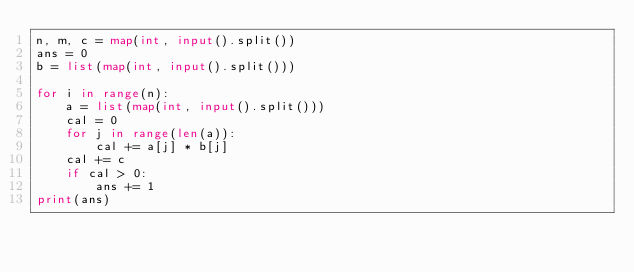Convert code to text. <code><loc_0><loc_0><loc_500><loc_500><_Python_>n, m, c = map(int, input().split())
ans = 0
b = list(map(int, input().split()))

for i in range(n):
    a = list(map(int, input().split()))
    cal = 0
    for j in range(len(a)):
        cal += a[j] * b[j]
    cal += c
    if cal > 0:
        ans += 1
print(ans)
</code> 